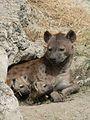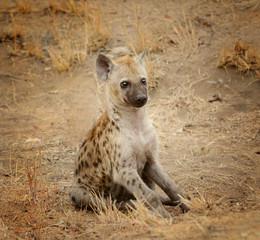The first image is the image on the left, the second image is the image on the right. For the images shown, is this caption "Each image contains exactly one hyena, and each hyena pictured has its head on the left of the image." true? Answer yes or no. No. The first image is the image on the left, the second image is the image on the right. Given the left and right images, does the statement "The animals in both pictures are facing left." hold true? Answer yes or no. No. 